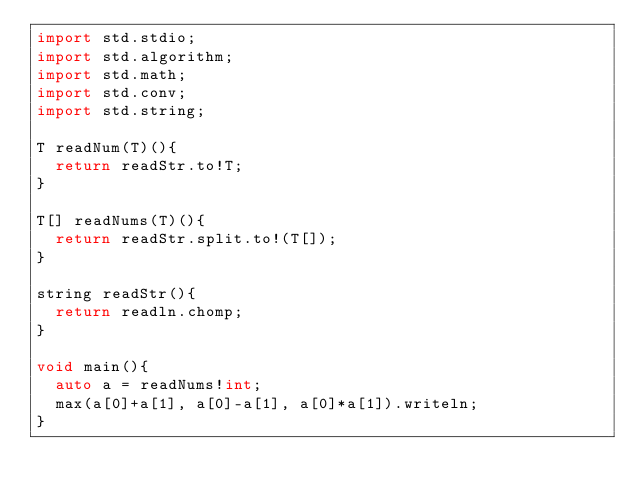Convert code to text. <code><loc_0><loc_0><loc_500><loc_500><_D_>import std.stdio;
import std.algorithm;
import std.math;
import std.conv;
import std.string;

T readNum(T)(){
  return readStr.to!T;
}

T[] readNums(T)(){
  return readStr.split.to!(T[]);
}

string readStr(){
  return readln.chomp;
}

void main(){
  auto a = readNums!int;
  max(a[0]+a[1], a[0]-a[1], a[0]*a[1]).writeln;
}
</code> 